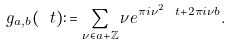<formula> <loc_0><loc_0><loc_500><loc_500>g _ { a , b } ( \ t ) \colon = \sum _ { \nu \in a + \mathbb { Z } } \nu e ^ { \pi i \nu ^ { 2 } \ t + 2 \pi i \nu b } .</formula> 